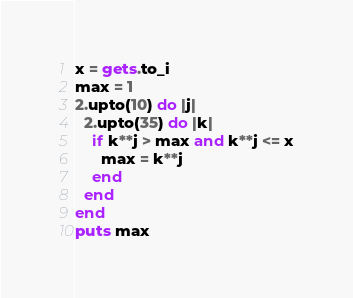<code> <loc_0><loc_0><loc_500><loc_500><_Ruby_>x = gets.to_i
max = 1
2.upto(10) do |j|
  2.upto(35) do |k|
    if k**j > max and k**j <= x
      max = k**j
    end
  end
end
puts max
</code> 